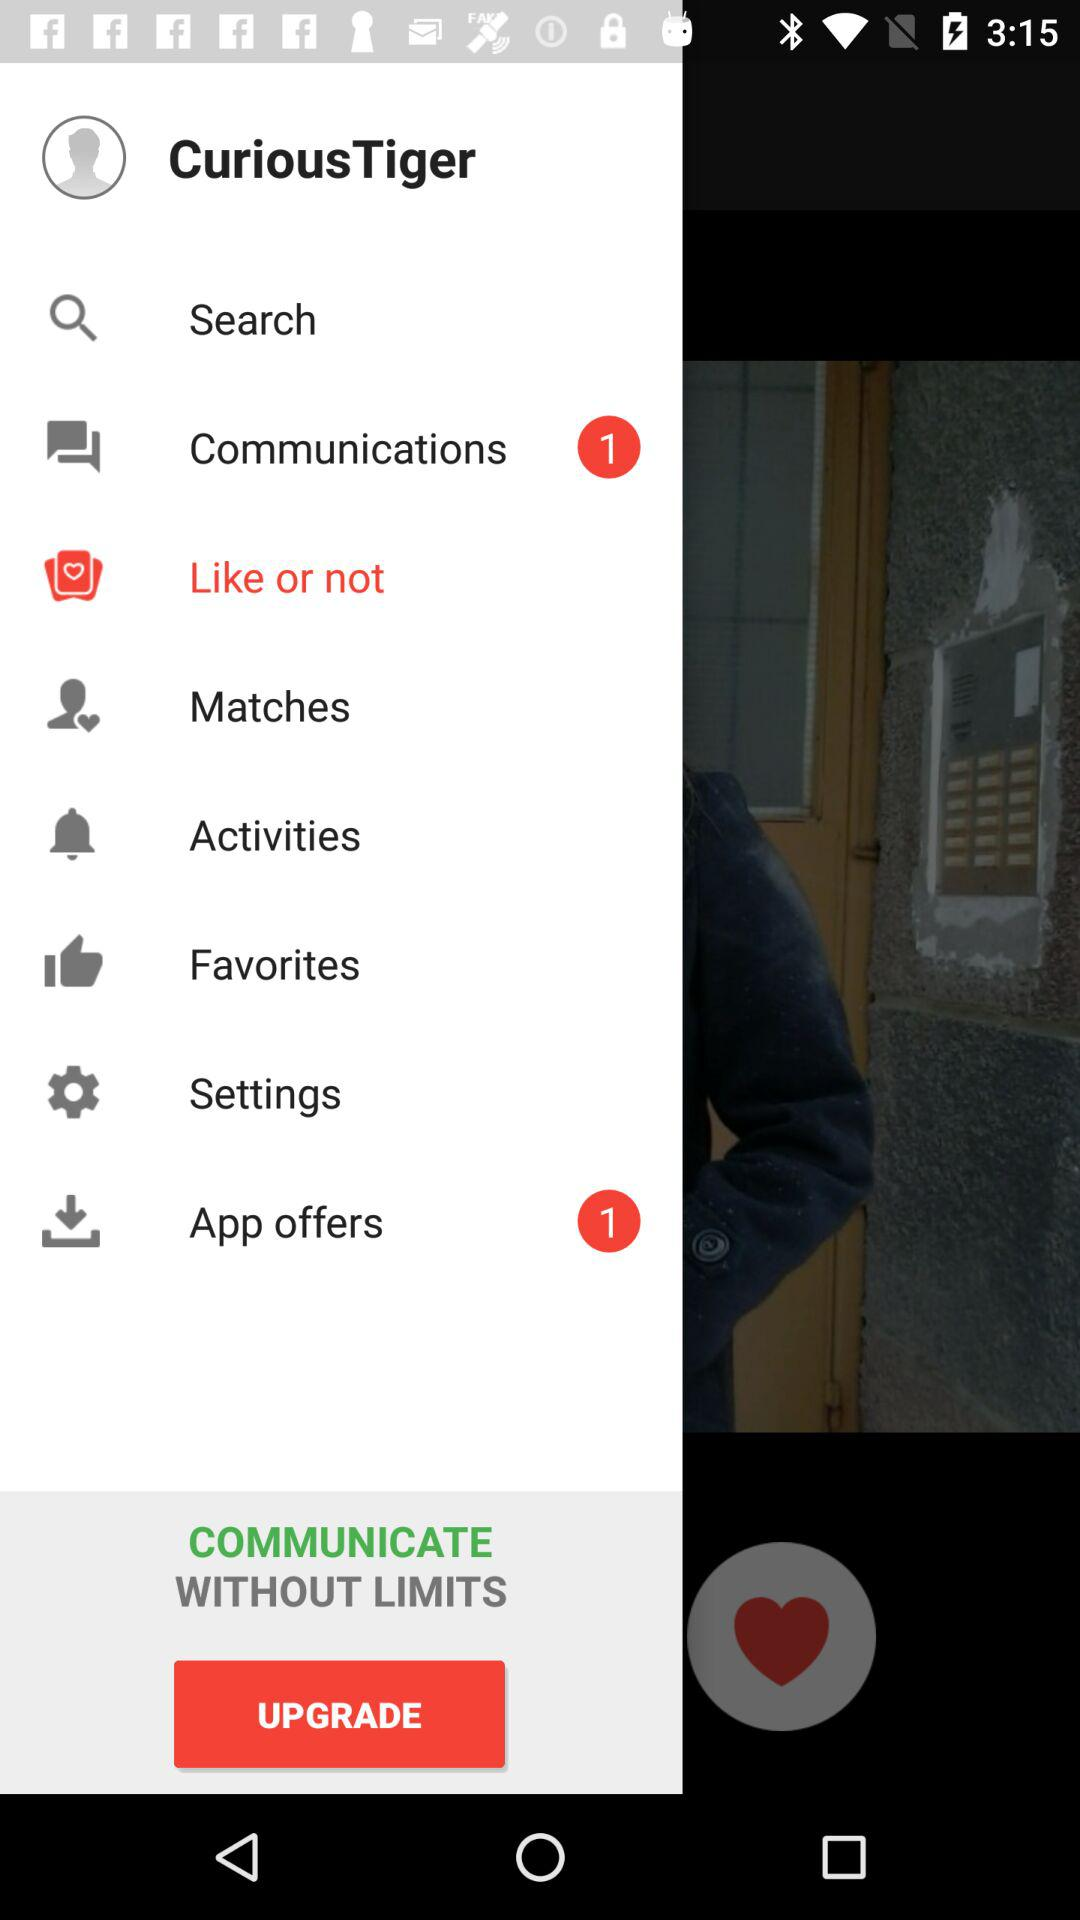Which item is selected? The selected item is "Like or not". 